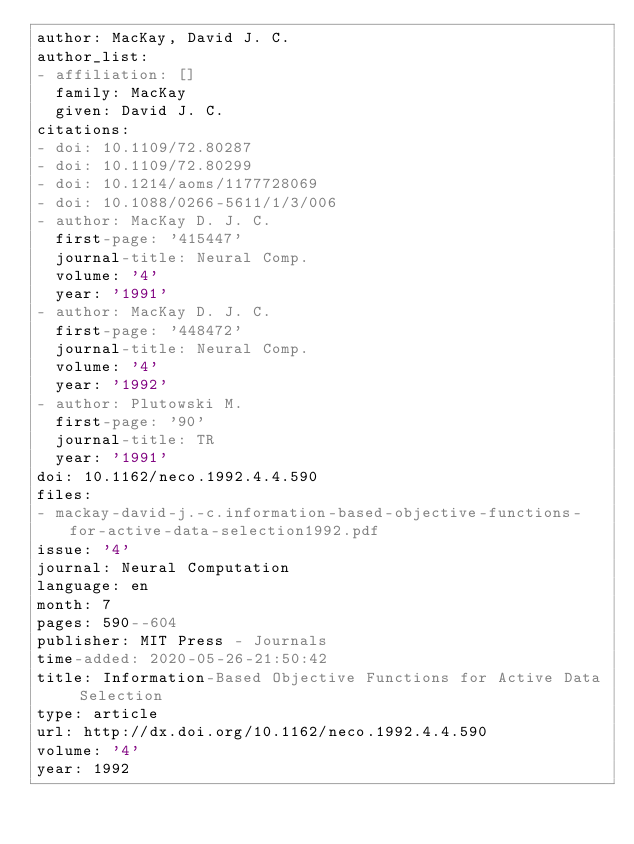<code> <loc_0><loc_0><loc_500><loc_500><_YAML_>author: MacKay, David J. C.
author_list:
- affiliation: []
  family: MacKay
  given: David J. C.
citations:
- doi: 10.1109/72.80287
- doi: 10.1109/72.80299
- doi: 10.1214/aoms/1177728069
- doi: 10.1088/0266-5611/1/3/006
- author: MacKay D. J. C.
  first-page: '415447'
  journal-title: Neural Comp.
  volume: '4'
  year: '1991'
- author: MacKay D. J. C.
  first-page: '448472'
  journal-title: Neural Comp.
  volume: '4'
  year: '1992'
- author: Plutowski M.
  first-page: '90'
  journal-title: TR
  year: '1991'
doi: 10.1162/neco.1992.4.4.590
files:
- mackay-david-j.-c.information-based-objective-functions-for-active-data-selection1992.pdf
issue: '4'
journal: Neural Computation
language: en
month: 7
pages: 590--604
publisher: MIT Press - Journals
time-added: 2020-05-26-21:50:42
title: Information-Based Objective Functions for Active Data Selection
type: article
url: http://dx.doi.org/10.1162/neco.1992.4.4.590
volume: '4'
year: 1992
</code> 